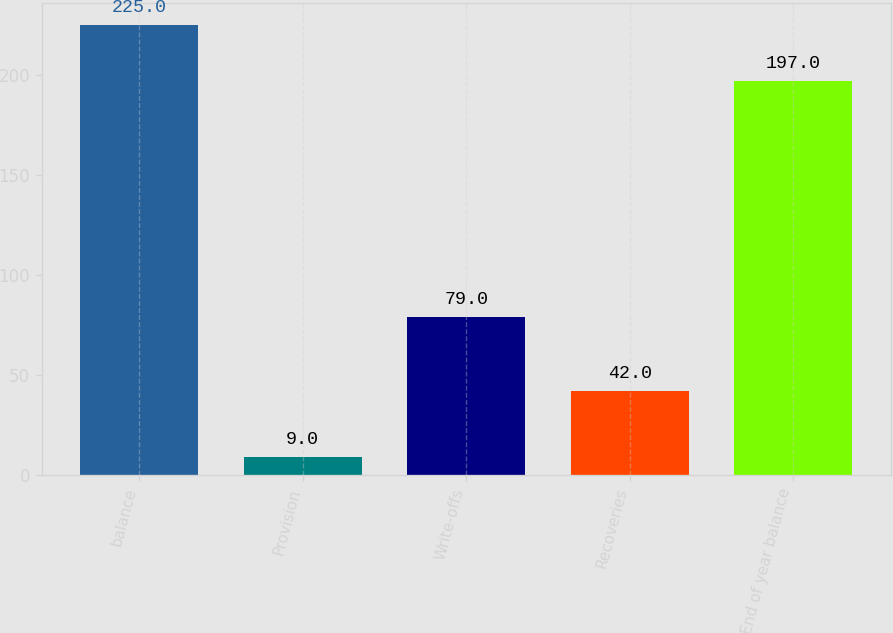Convert chart to OTSL. <chart><loc_0><loc_0><loc_500><loc_500><bar_chart><fcel>balance<fcel>Provision<fcel>Write-offs<fcel>Recoveries<fcel>End of year balance<nl><fcel>225<fcel>9<fcel>79<fcel>42<fcel>197<nl></chart> 